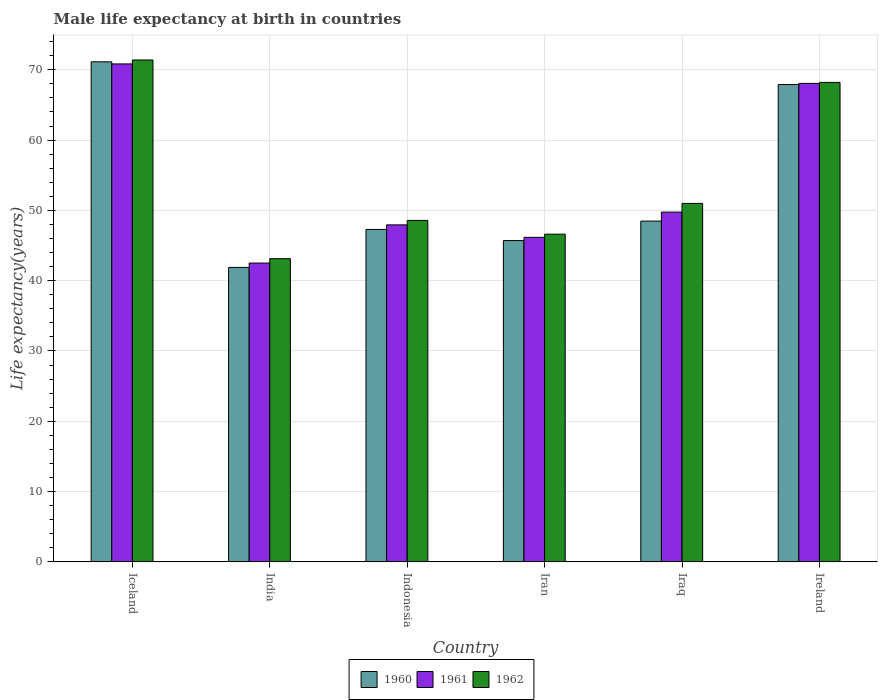How many groups of bars are there?
Provide a short and direct response. 6. Are the number of bars per tick equal to the number of legend labels?
Offer a terse response. Yes. How many bars are there on the 6th tick from the right?
Your answer should be very brief. 3. What is the label of the 5th group of bars from the left?
Provide a short and direct response. Iraq. In how many cases, is the number of bars for a given country not equal to the number of legend labels?
Give a very brief answer. 0. What is the male life expectancy at birth in 1960 in Iraq?
Make the answer very short. 48.48. Across all countries, what is the maximum male life expectancy at birth in 1962?
Offer a terse response. 71.4. Across all countries, what is the minimum male life expectancy at birth in 1962?
Your answer should be very brief. 43.13. What is the total male life expectancy at birth in 1960 in the graph?
Offer a very short reply. 322.4. What is the difference between the male life expectancy at birth in 1962 in India and that in Iran?
Give a very brief answer. -3.48. What is the difference between the male life expectancy at birth in 1960 in Iraq and the male life expectancy at birth in 1962 in Indonesia?
Give a very brief answer. -0.1. What is the average male life expectancy at birth in 1960 per country?
Make the answer very short. 53.73. What is the difference between the male life expectancy at birth of/in 1961 and male life expectancy at birth of/in 1960 in Ireland?
Give a very brief answer. 0.17. In how many countries, is the male life expectancy at birth in 1960 greater than 62 years?
Offer a terse response. 2. What is the ratio of the male life expectancy at birth in 1962 in Iran to that in Iraq?
Keep it short and to the point. 0.91. Is the difference between the male life expectancy at birth in 1961 in India and Ireland greater than the difference between the male life expectancy at birth in 1960 in India and Ireland?
Offer a very short reply. Yes. What is the difference between the highest and the second highest male life expectancy at birth in 1961?
Provide a short and direct response. -18.31. What is the difference between the highest and the lowest male life expectancy at birth in 1961?
Your answer should be very brief. 28.33. Is the sum of the male life expectancy at birth in 1962 in Iran and Iraq greater than the maximum male life expectancy at birth in 1960 across all countries?
Give a very brief answer. Yes. Is it the case that in every country, the sum of the male life expectancy at birth in 1961 and male life expectancy at birth in 1960 is greater than the male life expectancy at birth in 1962?
Your response must be concise. Yes. Are all the bars in the graph horizontal?
Your answer should be compact. No. Are the values on the major ticks of Y-axis written in scientific E-notation?
Provide a short and direct response. No. Does the graph contain grids?
Make the answer very short. Yes. Where does the legend appear in the graph?
Provide a succinct answer. Bottom center. How many legend labels are there?
Your answer should be very brief. 3. How are the legend labels stacked?
Your answer should be very brief. Horizontal. What is the title of the graph?
Your answer should be compact. Male life expectancy at birth in countries. Does "1975" appear as one of the legend labels in the graph?
Give a very brief answer. No. What is the label or title of the X-axis?
Offer a terse response. Country. What is the label or title of the Y-axis?
Ensure brevity in your answer.  Life expectancy(years). What is the Life expectancy(years) in 1960 in Iceland?
Your answer should be very brief. 71.14. What is the Life expectancy(years) in 1961 in Iceland?
Your answer should be compact. 70.84. What is the Life expectancy(years) of 1962 in Iceland?
Your answer should be compact. 71.4. What is the Life expectancy(years) of 1960 in India?
Give a very brief answer. 41.89. What is the Life expectancy(years) in 1961 in India?
Give a very brief answer. 42.51. What is the Life expectancy(years) in 1962 in India?
Ensure brevity in your answer.  43.13. What is the Life expectancy(years) of 1960 in Indonesia?
Your response must be concise. 47.29. What is the Life expectancy(years) of 1961 in Indonesia?
Keep it short and to the point. 47.94. What is the Life expectancy(years) in 1962 in Indonesia?
Give a very brief answer. 48.58. What is the Life expectancy(years) of 1960 in Iran?
Keep it short and to the point. 45.71. What is the Life expectancy(years) of 1961 in Iran?
Ensure brevity in your answer.  46.17. What is the Life expectancy(years) in 1962 in Iran?
Your response must be concise. 46.62. What is the Life expectancy(years) in 1960 in Iraq?
Your answer should be very brief. 48.48. What is the Life expectancy(years) of 1961 in Iraq?
Your response must be concise. 49.76. What is the Life expectancy(years) in 1962 in Iraq?
Keep it short and to the point. 50.99. What is the Life expectancy(years) of 1960 in Ireland?
Provide a short and direct response. 67.9. What is the Life expectancy(years) of 1961 in Ireland?
Provide a succinct answer. 68.07. What is the Life expectancy(years) in 1962 in Ireland?
Keep it short and to the point. 68.21. Across all countries, what is the maximum Life expectancy(years) in 1960?
Make the answer very short. 71.14. Across all countries, what is the maximum Life expectancy(years) in 1961?
Provide a succinct answer. 70.84. Across all countries, what is the maximum Life expectancy(years) in 1962?
Provide a short and direct response. 71.4. Across all countries, what is the minimum Life expectancy(years) of 1960?
Your answer should be compact. 41.89. Across all countries, what is the minimum Life expectancy(years) of 1961?
Your answer should be very brief. 42.51. Across all countries, what is the minimum Life expectancy(years) in 1962?
Provide a succinct answer. 43.13. What is the total Life expectancy(years) in 1960 in the graph?
Make the answer very short. 322.4. What is the total Life expectancy(years) in 1961 in the graph?
Your response must be concise. 325.29. What is the total Life expectancy(years) in 1962 in the graph?
Make the answer very short. 328.93. What is the difference between the Life expectancy(years) in 1960 in Iceland and that in India?
Make the answer very short. 29.25. What is the difference between the Life expectancy(years) of 1961 in Iceland and that in India?
Your answer should be compact. 28.33. What is the difference between the Life expectancy(years) in 1962 in Iceland and that in India?
Offer a very short reply. 28.27. What is the difference between the Life expectancy(years) of 1960 in Iceland and that in Indonesia?
Your response must be concise. 23.84. What is the difference between the Life expectancy(years) of 1961 in Iceland and that in Indonesia?
Offer a terse response. 22.9. What is the difference between the Life expectancy(years) of 1962 in Iceland and that in Indonesia?
Keep it short and to the point. 22.82. What is the difference between the Life expectancy(years) in 1960 in Iceland and that in Iran?
Offer a terse response. 25.43. What is the difference between the Life expectancy(years) of 1961 in Iceland and that in Iran?
Keep it short and to the point. 24.67. What is the difference between the Life expectancy(years) of 1962 in Iceland and that in Iran?
Offer a very short reply. 24.78. What is the difference between the Life expectancy(years) of 1960 in Iceland and that in Iraq?
Provide a succinct answer. 22.66. What is the difference between the Life expectancy(years) of 1961 in Iceland and that in Iraq?
Offer a very short reply. 21.08. What is the difference between the Life expectancy(years) in 1962 in Iceland and that in Iraq?
Your response must be concise. 20.41. What is the difference between the Life expectancy(years) of 1960 in Iceland and that in Ireland?
Your answer should be very brief. 3.23. What is the difference between the Life expectancy(years) of 1961 in Iceland and that in Ireland?
Make the answer very short. 2.77. What is the difference between the Life expectancy(years) of 1962 in Iceland and that in Ireland?
Your response must be concise. 3.19. What is the difference between the Life expectancy(years) in 1960 in India and that in Indonesia?
Give a very brief answer. -5.4. What is the difference between the Life expectancy(years) of 1961 in India and that in Indonesia?
Your answer should be compact. -5.43. What is the difference between the Life expectancy(years) in 1962 in India and that in Indonesia?
Provide a succinct answer. -5.44. What is the difference between the Life expectancy(years) of 1960 in India and that in Iran?
Ensure brevity in your answer.  -3.82. What is the difference between the Life expectancy(years) of 1961 in India and that in Iran?
Provide a succinct answer. -3.66. What is the difference between the Life expectancy(years) in 1962 in India and that in Iran?
Your answer should be very brief. -3.48. What is the difference between the Life expectancy(years) in 1960 in India and that in Iraq?
Offer a very short reply. -6.59. What is the difference between the Life expectancy(years) in 1961 in India and that in Iraq?
Ensure brevity in your answer.  -7.25. What is the difference between the Life expectancy(years) in 1962 in India and that in Iraq?
Your answer should be very brief. -7.86. What is the difference between the Life expectancy(years) of 1960 in India and that in Ireland?
Offer a very short reply. -26.01. What is the difference between the Life expectancy(years) in 1961 in India and that in Ireland?
Provide a succinct answer. -25.56. What is the difference between the Life expectancy(years) in 1962 in India and that in Ireland?
Offer a very short reply. -25.07. What is the difference between the Life expectancy(years) of 1960 in Indonesia and that in Iran?
Keep it short and to the point. 1.59. What is the difference between the Life expectancy(years) in 1961 in Indonesia and that in Iran?
Your answer should be compact. 1.77. What is the difference between the Life expectancy(years) in 1962 in Indonesia and that in Iran?
Keep it short and to the point. 1.96. What is the difference between the Life expectancy(years) in 1960 in Indonesia and that in Iraq?
Keep it short and to the point. -1.19. What is the difference between the Life expectancy(years) of 1961 in Indonesia and that in Iraq?
Keep it short and to the point. -1.81. What is the difference between the Life expectancy(years) of 1962 in Indonesia and that in Iraq?
Offer a terse response. -2.42. What is the difference between the Life expectancy(years) of 1960 in Indonesia and that in Ireland?
Offer a very short reply. -20.61. What is the difference between the Life expectancy(years) of 1961 in Indonesia and that in Ireland?
Provide a short and direct response. -20.13. What is the difference between the Life expectancy(years) of 1962 in Indonesia and that in Ireland?
Offer a very short reply. -19.63. What is the difference between the Life expectancy(years) in 1960 in Iran and that in Iraq?
Provide a short and direct response. -2.77. What is the difference between the Life expectancy(years) in 1961 in Iran and that in Iraq?
Your response must be concise. -3.59. What is the difference between the Life expectancy(years) in 1962 in Iran and that in Iraq?
Your answer should be compact. -4.38. What is the difference between the Life expectancy(years) in 1960 in Iran and that in Ireland?
Offer a terse response. -22.2. What is the difference between the Life expectancy(years) of 1961 in Iran and that in Ireland?
Your answer should be very brief. -21.9. What is the difference between the Life expectancy(years) in 1962 in Iran and that in Ireland?
Your response must be concise. -21.59. What is the difference between the Life expectancy(years) of 1960 in Iraq and that in Ireland?
Provide a short and direct response. -19.42. What is the difference between the Life expectancy(years) in 1961 in Iraq and that in Ireland?
Your answer should be compact. -18.31. What is the difference between the Life expectancy(years) of 1962 in Iraq and that in Ireland?
Provide a short and direct response. -17.21. What is the difference between the Life expectancy(years) in 1960 in Iceland and the Life expectancy(years) in 1961 in India?
Provide a succinct answer. 28.62. What is the difference between the Life expectancy(years) of 1960 in Iceland and the Life expectancy(years) of 1962 in India?
Make the answer very short. 28. What is the difference between the Life expectancy(years) of 1961 in Iceland and the Life expectancy(years) of 1962 in India?
Your answer should be very brief. 27.71. What is the difference between the Life expectancy(years) in 1960 in Iceland and the Life expectancy(years) in 1961 in Indonesia?
Make the answer very short. 23.19. What is the difference between the Life expectancy(years) in 1960 in Iceland and the Life expectancy(years) in 1962 in Indonesia?
Ensure brevity in your answer.  22.56. What is the difference between the Life expectancy(years) of 1961 in Iceland and the Life expectancy(years) of 1962 in Indonesia?
Offer a terse response. 22.26. What is the difference between the Life expectancy(years) in 1960 in Iceland and the Life expectancy(years) in 1961 in Iran?
Give a very brief answer. 24.97. What is the difference between the Life expectancy(years) of 1960 in Iceland and the Life expectancy(years) of 1962 in Iran?
Offer a terse response. 24.52. What is the difference between the Life expectancy(years) of 1961 in Iceland and the Life expectancy(years) of 1962 in Iran?
Give a very brief answer. 24.22. What is the difference between the Life expectancy(years) in 1960 in Iceland and the Life expectancy(years) in 1961 in Iraq?
Provide a short and direct response. 21.38. What is the difference between the Life expectancy(years) of 1960 in Iceland and the Life expectancy(years) of 1962 in Iraq?
Keep it short and to the point. 20.14. What is the difference between the Life expectancy(years) in 1961 in Iceland and the Life expectancy(years) in 1962 in Iraq?
Give a very brief answer. 19.85. What is the difference between the Life expectancy(years) in 1960 in Iceland and the Life expectancy(years) in 1961 in Ireland?
Provide a succinct answer. 3.07. What is the difference between the Life expectancy(years) in 1960 in Iceland and the Life expectancy(years) in 1962 in Ireland?
Your answer should be compact. 2.93. What is the difference between the Life expectancy(years) in 1961 in Iceland and the Life expectancy(years) in 1962 in Ireland?
Provide a succinct answer. 2.63. What is the difference between the Life expectancy(years) in 1960 in India and the Life expectancy(years) in 1961 in Indonesia?
Provide a short and direct response. -6.05. What is the difference between the Life expectancy(years) in 1960 in India and the Life expectancy(years) in 1962 in Indonesia?
Provide a short and direct response. -6.69. What is the difference between the Life expectancy(years) in 1961 in India and the Life expectancy(years) in 1962 in Indonesia?
Provide a short and direct response. -6.07. What is the difference between the Life expectancy(years) in 1960 in India and the Life expectancy(years) in 1961 in Iran?
Offer a terse response. -4.28. What is the difference between the Life expectancy(years) of 1960 in India and the Life expectancy(years) of 1962 in Iran?
Your response must be concise. -4.73. What is the difference between the Life expectancy(years) of 1961 in India and the Life expectancy(years) of 1962 in Iran?
Keep it short and to the point. -4.11. What is the difference between the Life expectancy(years) in 1960 in India and the Life expectancy(years) in 1961 in Iraq?
Your answer should be very brief. -7.87. What is the difference between the Life expectancy(years) in 1960 in India and the Life expectancy(years) in 1962 in Iraq?
Make the answer very short. -9.1. What is the difference between the Life expectancy(years) in 1961 in India and the Life expectancy(years) in 1962 in Iraq?
Make the answer very short. -8.48. What is the difference between the Life expectancy(years) in 1960 in India and the Life expectancy(years) in 1961 in Ireland?
Provide a succinct answer. -26.18. What is the difference between the Life expectancy(years) in 1960 in India and the Life expectancy(years) in 1962 in Ireland?
Your response must be concise. -26.32. What is the difference between the Life expectancy(years) of 1961 in India and the Life expectancy(years) of 1962 in Ireland?
Provide a succinct answer. -25.7. What is the difference between the Life expectancy(years) of 1960 in Indonesia and the Life expectancy(years) of 1961 in Iran?
Keep it short and to the point. 1.13. What is the difference between the Life expectancy(years) in 1960 in Indonesia and the Life expectancy(years) in 1962 in Iran?
Keep it short and to the point. 0.68. What is the difference between the Life expectancy(years) in 1961 in Indonesia and the Life expectancy(years) in 1962 in Iran?
Your answer should be very brief. 1.32. What is the difference between the Life expectancy(years) of 1960 in Indonesia and the Life expectancy(years) of 1961 in Iraq?
Make the answer very short. -2.46. What is the difference between the Life expectancy(years) in 1961 in Indonesia and the Life expectancy(years) in 1962 in Iraq?
Offer a terse response. -3.05. What is the difference between the Life expectancy(years) of 1960 in Indonesia and the Life expectancy(years) of 1961 in Ireland?
Your response must be concise. -20.78. What is the difference between the Life expectancy(years) in 1960 in Indonesia and the Life expectancy(years) in 1962 in Ireland?
Offer a terse response. -20.91. What is the difference between the Life expectancy(years) of 1961 in Indonesia and the Life expectancy(years) of 1962 in Ireland?
Your answer should be very brief. -20.27. What is the difference between the Life expectancy(years) of 1960 in Iran and the Life expectancy(years) of 1961 in Iraq?
Make the answer very short. -4.05. What is the difference between the Life expectancy(years) of 1960 in Iran and the Life expectancy(years) of 1962 in Iraq?
Ensure brevity in your answer.  -5.29. What is the difference between the Life expectancy(years) in 1961 in Iran and the Life expectancy(years) in 1962 in Iraq?
Keep it short and to the point. -4.83. What is the difference between the Life expectancy(years) of 1960 in Iran and the Life expectancy(years) of 1961 in Ireland?
Provide a short and direct response. -22.36. What is the difference between the Life expectancy(years) in 1960 in Iran and the Life expectancy(years) in 1962 in Ireland?
Your answer should be very brief. -22.5. What is the difference between the Life expectancy(years) in 1961 in Iran and the Life expectancy(years) in 1962 in Ireland?
Make the answer very short. -22.04. What is the difference between the Life expectancy(years) in 1960 in Iraq and the Life expectancy(years) in 1961 in Ireland?
Provide a succinct answer. -19.59. What is the difference between the Life expectancy(years) of 1960 in Iraq and the Life expectancy(years) of 1962 in Ireland?
Keep it short and to the point. -19.73. What is the difference between the Life expectancy(years) of 1961 in Iraq and the Life expectancy(years) of 1962 in Ireland?
Your answer should be compact. -18.45. What is the average Life expectancy(years) of 1960 per country?
Provide a succinct answer. 53.73. What is the average Life expectancy(years) of 1961 per country?
Keep it short and to the point. 54.21. What is the average Life expectancy(years) in 1962 per country?
Provide a short and direct response. 54.82. What is the difference between the Life expectancy(years) of 1960 and Life expectancy(years) of 1961 in Iceland?
Make the answer very short. 0.29. What is the difference between the Life expectancy(years) in 1960 and Life expectancy(years) in 1962 in Iceland?
Provide a short and direct response. -0.27. What is the difference between the Life expectancy(years) in 1961 and Life expectancy(years) in 1962 in Iceland?
Offer a terse response. -0.56. What is the difference between the Life expectancy(years) of 1960 and Life expectancy(years) of 1961 in India?
Your answer should be compact. -0.62. What is the difference between the Life expectancy(years) of 1960 and Life expectancy(years) of 1962 in India?
Provide a succinct answer. -1.24. What is the difference between the Life expectancy(years) in 1961 and Life expectancy(years) in 1962 in India?
Keep it short and to the point. -0.62. What is the difference between the Life expectancy(years) in 1960 and Life expectancy(years) in 1961 in Indonesia?
Offer a very short reply. -0.65. What is the difference between the Life expectancy(years) in 1960 and Life expectancy(years) in 1962 in Indonesia?
Provide a short and direct response. -1.28. What is the difference between the Life expectancy(years) of 1961 and Life expectancy(years) of 1962 in Indonesia?
Your response must be concise. -0.64. What is the difference between the Life expectancy(years) in 1960 and Life expectancy(years) in 1961 in Iran?
Keep it short and to the point. -0.46. What is the difference between the Life expectancy(years) of 1960 and Life expectancy(years) of 1962 in Iran?
Offer a terse response. -0.91. What is the difference between the Life expectancy(years) in 1961 and Life expectancy(years) in 1962 in Iran?
Your response must be concise. -0.45. What is the difference between the Life expectancy(years) of 1960 and Life expectancy(years) of 1961 in Iraq?
Provide a succinct answer. -1.28. What is the difference between the Life expectancy(years) in 1960 and Life expectancy(years) in 1962 in Iraq?
Your answer should be compact. -2.52. What is the difference between the Life expectancy(years) in 1961 and Life expectancy(years) in 1962 in Iraq?
Your response must be concise. -1.24. What is the difference between the Life expectancy(years) in 1960 and Life expectancy(years) in 1961 in Ireland?
Keep it short and to the point. -0.17. What is the difference between the Life expectancy(years) in 1960 and Life expectancy(years) in 1962 in Ireland?
Your answer should be compact. -0.3. What is the difference between the Life expectancy(years) in 1961 and Life expectancy(years) in 1962 in Ireland?
Offer a terse response. -0.14. What is the ratio of the Life expectancy(years) of 1960 in Iceland to that in India?
Provide a short and direct response. 1.7. What is the ratio of the Life expectancy(years) of 1961 in Iceland to that in India?
Keep it short and to the point. 1.67. What is the ratio of the Life expectancy(years) of 1962 in Iceland to that in India?
Keep it short and to the point. 1.66. What is the ratio of the Life expectancy(years) of 1960 in Iceland to that in Indonesia?
Your response must be concise. 1.5. What is the ratio of the Life expectancy(years) in 1961 in Iceland to that in Indonesia?
Give a very brief answer. 1.48. What is the ratio of the Life expectancy(years) of 1962 in Iceland to that in Indonesia?
Ensure brevity in your answer.  1.47. What is the ratio of the Life expectancy(years) of 1960 in Iceland to that in Iran?
Offer a terse response. 1.56. What is the ratio of the Life expectancy(years) of 1961 in Iceland to that in Iran?
Keep it short and to the point. 1.53. What is the ratio of the Life expectancy(years) in 1962 in Iceland to that in Iran?
Give a very brief answer. 1.53. What is the ratio of the Life expectancy(years) in 1960 in Iceland to that in Iraq?
Offer a very short reply. 1.47. What is the ratio of the Life expectancy(years) of 1961 in Iceland to that in Iraq?
Offer a very short reply. 1.42. What is the ratio of the Life expectancy(years) of 1962 in Iceland to that in Iraq?
Your response must be concise. 1.4. What is the ratio of the Life expectancy(years) of 1960 in Iceland to that in Ireland?
Provide a short and direct response. 1.05. What is the ratio of the Life expectancy(years) in 1961 in Iceland to that in Ireland?
Keep it short and to the point. 1.04. What is the ratio of the Life expectancy(years) of 1962 in Iceland to that in Ireland?
Offer a very short reply. 1.05. What is the ratio of the Life expectancy(years) in 1960 in India to that in Indonesia?
Your response must be concise. 0.89. What is the ratio of the Life expectancy(years) in 1961 in India to that in Indonesia?
Your answer should be very brief. 0.89. What is the ratio of the Life expectancy(years) in 1962 in India to that in Indonesia?
Keep it short and to the point. 0.89. What is the ratio of the Life expectancy(years) in 1960 in India to that in Iran?
Offer a very short reply. 0.92. What is the ratio of the Life expectancy(years) of 1961 in India to that in Iran?
Your response must be concise. 0.92. What is the ratio of the Life expectancy(years) of 1962 in India to that in Iran?
Provide a succinct answer. 0.93. What is the ratio of the Life expectancy(years) in 1960 in India to that in Iraq?
Give a very brief answer. 0.86. What is the ratio of the Life expectancy(years) in 1961 in India to that in Iraq?
Provide a succinct answer. 0.85. What is the ratio of the Life expectancy(years) of 1962 in India to that in Iraq?
Your response must be concise. 0.85. What is the ratio of the Life expectancy(years) in 1960 in India to that in Ireland?
Your response must be concise. 0.62. What is the ratio of the Life expectancy(years) in 1961 in India to that in Ireland?
Provide a succinct answer. 0.62. What is the ratio of the Life expectancy(years) of 1962 in India to that in Ireland?
Ensure brevity in your answer.  0.63. What is the ratio of the Life expectancy(years) of 1960 in Indonesia to that in Iran?
Ensure brevity in your answer.  1.03. What is the ratio of the Life expectancy(years) in 1961 in Indonesia to that in Iran?
Your response must be concise. 1.04. What is the ratio of the Life expectancy(years) of 1962 in Indonesia to that in Iran?
Offer a very short reply. 1.04. What is the ratio of the Life expectancy(years) in 1960 in Indonesia to that in Iraq?
Offer a terse response. 0.98. What is the ratio of the Life expectancy(years) in 1961 in Indonesia to that in Iraq?
Keep it short and to the point. 0.96. What is the ratio of the Life expectancy(years) of 1962 in Indonesia to that in Iraq?
Your answer should be very brief. 0.95. What is the ratio of the Life expectancy(years) in 1960 in Indonesia to that in Ireland?
Your answer should be very brief. 0.7. What is the ratio of the Life expectancy(years) of 1961 in Indonesia to that in Ireland?
Provide a short and direct response. 0.7. What is the ratio of the Life expectancy(years) of 1962 in Indonesia to that in Ireland?
Offer a very short reply. 0.71. What is the ratio of the Life expectancy(years) of 1960 in Iran to that in Iraq?
Make the answer very short. 0.94. What is the ratio of the Life expectancy(years) of 1961 in Iran to that in Iraq?
Your response must be concise. 0.93. What is the ratio of the Life expectancy(years) in 1962 in Iran to that in Iraq?
Provide a succinct answer. 0.91. What is the ratio of the Life expectancy(years) in 1960 in Iran to that in Ireland?
Your answer should be compact. 0.67. What is the ratio of the Life expectancy(years) of 1961 in Iran to that in Ireland?
Your answer should be compact. 0.68. What is the ratio of the Life expectancy(years) in 1962 in Iran to that in Ireland?
Your answer should be compact. 0.68. What is the ratio of the Life expectancy(years) of 1960 in Iraq to that in Ireland?
Make the answer very short. 0.71. What is the ratio of the Life expectancy(years) of 1961 in Iraq to that in Ireland?
Your response must be concise. 0.73. What is the ratio of the Life expectancy(years) of 1962 in Iraq to that in Ireland?
Your answer should be very brief. 0.75. What is the difference between the highest and the second highest Life expectancy(years) in 1960?
Ensure brevity in your answer.  3.23. What is the difference between the highest and the second highest Life expectancy(years) of 1961?
Ensure brevity in your answer.  2.77. What is the difference between the highest and the second highest Life expectancy(years) in 1962?
Ensure brevity in your answer.  3.19. What is the difference between the highest and the lowest Life expectancy(years) of 1960?
Offer a terse response. 29.25. What is the difference between the highest and the lowest Life expectancy(years) in 1961?
Offer a terse response. 28.33. What is the difference between the highest and the lowest Life expectancy(years) in 1962?
Provide a short and direct response. 28.27. 